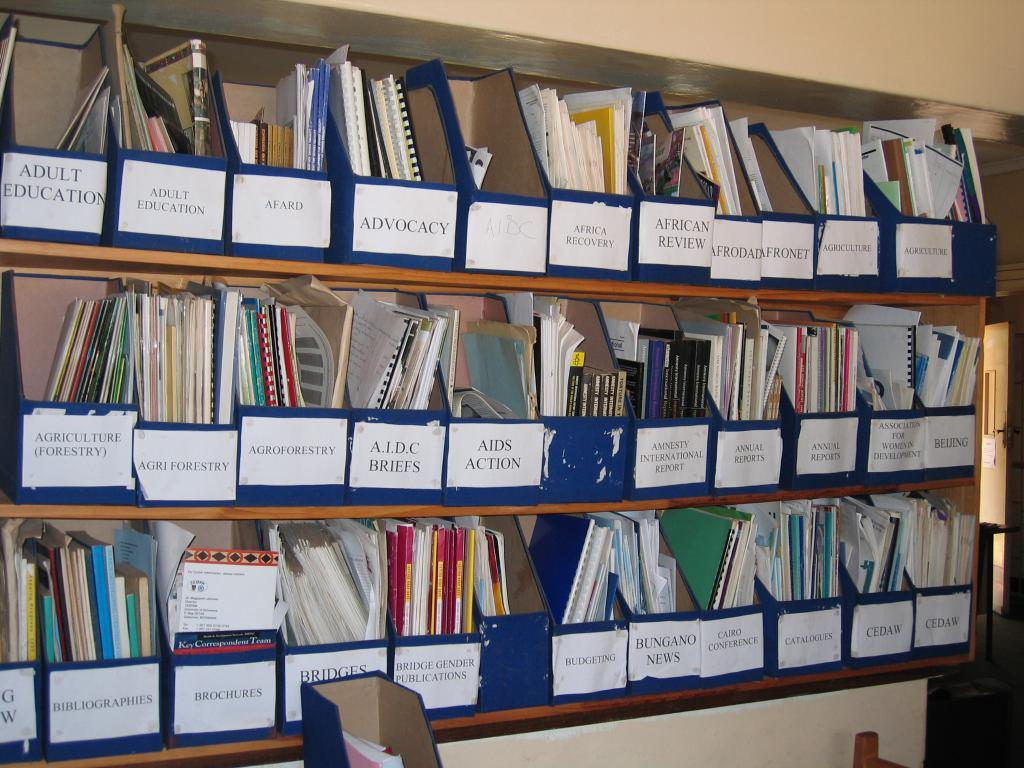<image>
Describe the image concisely. files are distributed in different bins such as Adult Education 